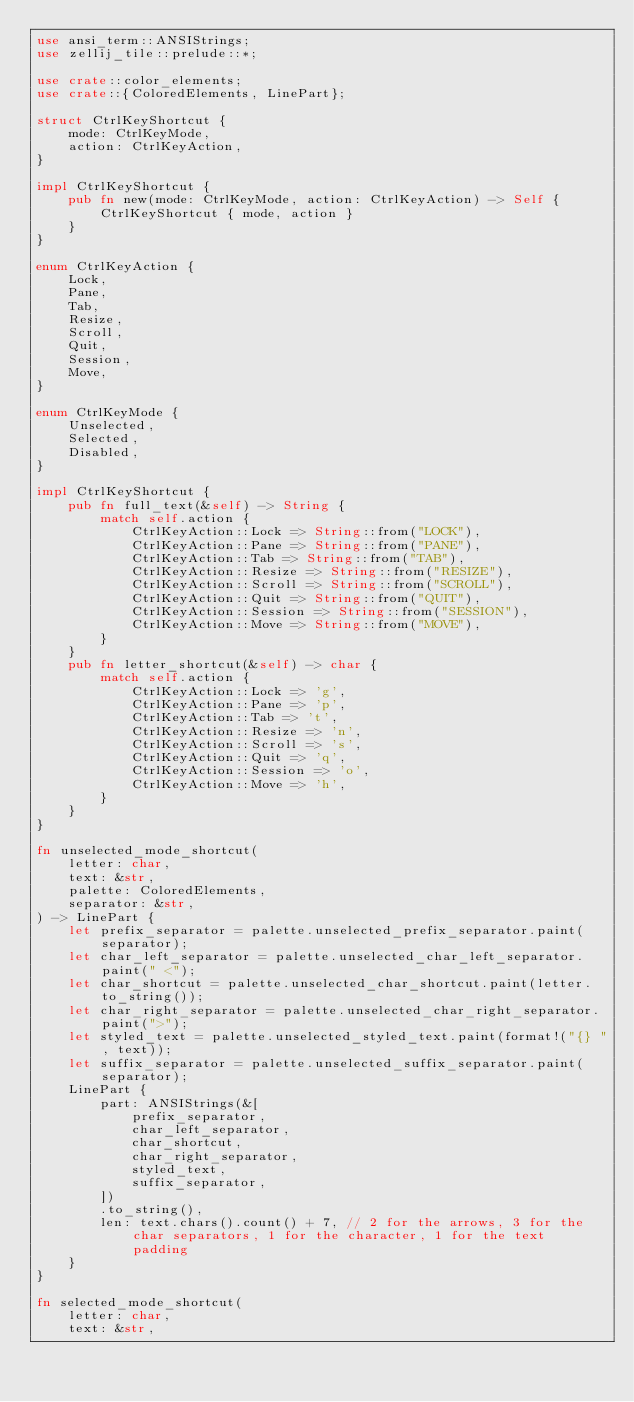Convert code to text. <code><loc_0><loc_0><loc_500><loc_500><_Rust_>use ansi_term::ANSIStrings;
use zellij_tile::prelude::*;

use crate::color_elements;
use crate::{ColoredElements, LinePart};

struct CtrlKeyShortcut {
    mode: CtrlKeyMode,
    action: CtrlKeyAction,
}

impl CtrlKeyShortcut {
    pub fn new(mode: CtrlKeyMode, action: CtrlKeyAction) -> Self {
        CtrlKeyShortcut { mode, action }
    }
}

enum CtrlKeyAction {
    Lock,
    Pane,
    Tab,
    Resize,
    Scroll,
    Quit,
    Session,
    Move,
}

enum CtrlKeyMode {
    Unselected,
    Selected,
    Disabled,
}

impl CtrlKeyShortcut {
    pub fn full_text(&self) -> String {
        match self.action {
            CtrlKeyAction::Lock => String::from("LOCK"),
            CtrlKeyAction::Pane => String::from("PANE"),
            CtrlKeyAction::Tab => String::from("TAB"),
            CtrlKeyAction::Resize => String::from("RESIZE"),
            CtrlKeyAction::Scroll => String::from("SCROLL"),
            CtrlKeyAction::Quit => String::from("QUIT"),
            CtrlKeyAction::Session => String::from("SESSION"),
            CtrlKeyAction::Move => String::from("MOVE"),
        }
    }
    pub fn letter_shortcut(&self) -> char {
        match self.action {
            CtrlKeyAction::Lock => 'g',
            CtrlKeyAction::Pane => 'p',
            CtrlKeyAction::Tab => 't',
            CtrlKeyAction::Resize => 'n',
            CtrlKeyAction::Scroll => 's',
            CtrlKeyAction::Quit => 'q',
            CtrlKeyAction::Session => 'o',
            CtrlKeyAction::Move => 'h',
        }
    }
}

fn unselected_mode_shortcut(
    letter: char,
    text: &str,
    palette: ColoredElements,
    separator: &str,
) -> LinePart {
    let prefix_separator = palette.unselected_prefix_separator.paint(separator);
    let char_left_separator = palette.unselected_char_left_separator.paint(" <");
    let char_shortcut = palette.unselected_char_shortcut.paint(letter.to_string());
    let char_right_separator = palette.unselected_char_right_separator.paint(">");
    let styled_text = palette.unselected_styled_text.paint(format!("{} ", text));
    let suffix_separator = palette.unselected_suffix_separator.paint(separator);
    LinePart {
        part: ANSIStrings(&[
            prefix_separator,
            char_left_separator,
            char_shortcut,
            char_right_separator,
            styled_text,
            suffix_separator,
        ])
        .to_string(),
        len: text.chars().count() + 7, // 2 for the arrows, 3 for the char separators, 1 for the character, 1 for the text padding
    }
}

fn selected_mode_shortcut(
    letter: char,
    text: &str,</code> 